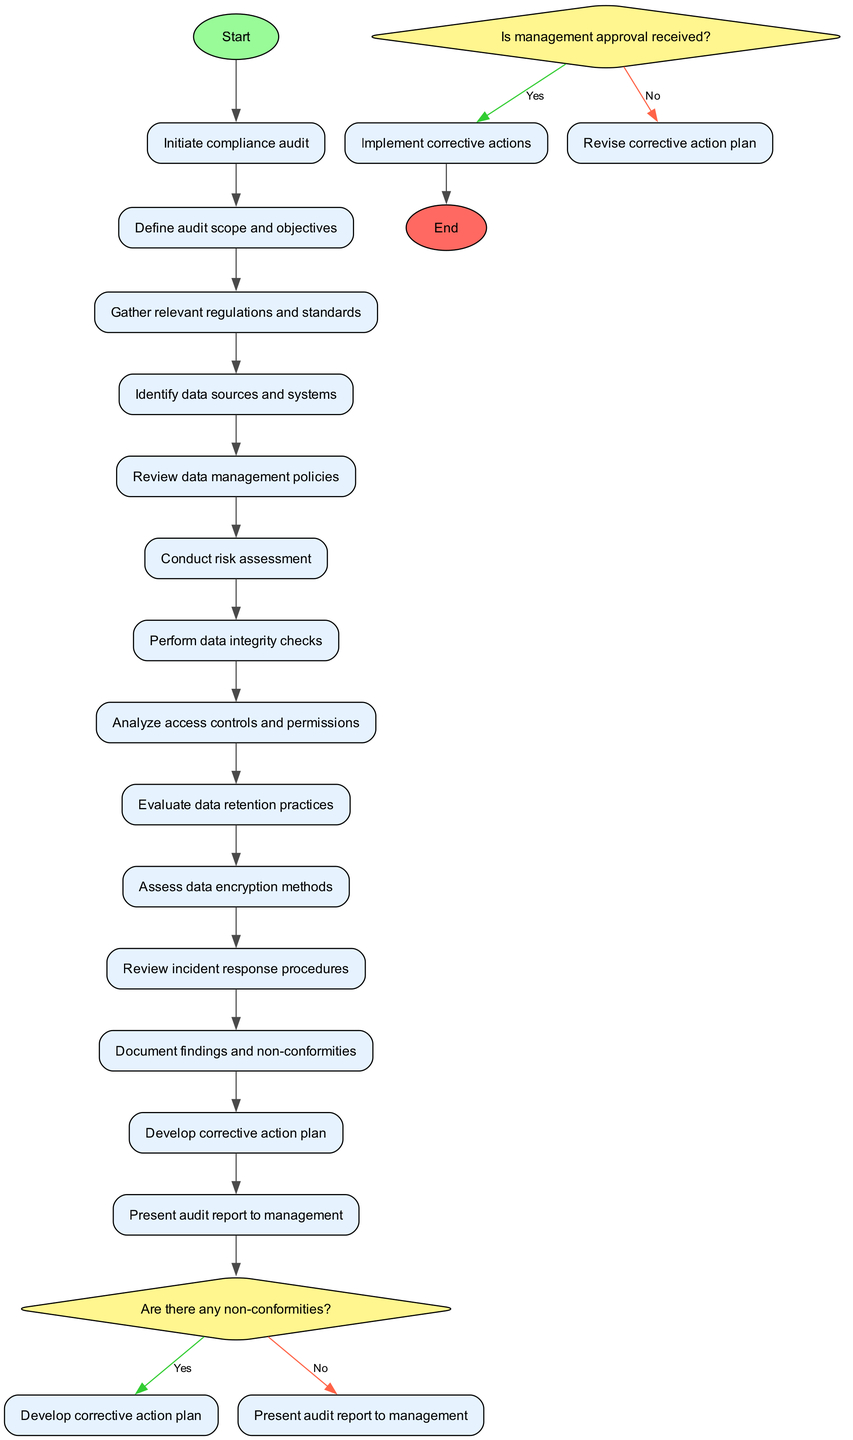What is the first activity in the compliance audit process? The first activity listed in the diagram is "Define audit scope and objectives," which follows the initiation of the compliance audit.
Answer: Define audit scope and objectives How many activities are there in the diagram? The diagram contains a total of 12 activities listed under the compliance audit process.
Answer: 12 What is the final step before closing the audit? The last activity before closing the audit is "Present audit report to management." It specifically indicates the last task completed in the process.
Answer: Present audit report to management What decision follows the activity "Document findings and non-conformities"? After documenting findings, the next step is a decision point asking, "Are there any non-conformities?" This decision determines the direction of the process based on the findings.
Answer: Are there any non-conformities? What happens if there are non-conformities identified? If non-conformities are identified, the process indicates that a "Develop corrective action plan" step should be undertaken. This outlines the corrective measures needed to address the issues.
Answer: Develop corrective action plan What is the question posed after the "Develop corrective action plan"? The question that follows this activity is "Is management approval received?" This decision point is crucial for determining the next steps in the compliance audit process.
Answer: Is management approval received? How does the diagram indicate a successful completion of the audit process? The successful completion of the audit process is indicated by reaching the "End" node after implementing corrective actions if management approval has been received.
Answer: End 